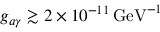Convert formula to latex. <formula><loc_0><loc_0><loc_500><loc_500>g _ { a \gamma } \gtrsim 2 \times 1 0 ^ { - 1 1 } \, G e V ^ { - 1 }</formula> 